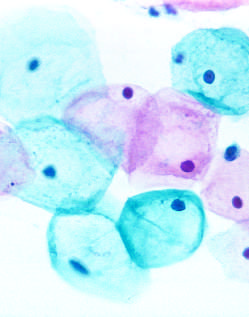what reflects the progressive loss of cellular differentiation on the surface of the cervical lesions from which these cells are exfoliated?
Answer the question using a single word or phrase. This observation 